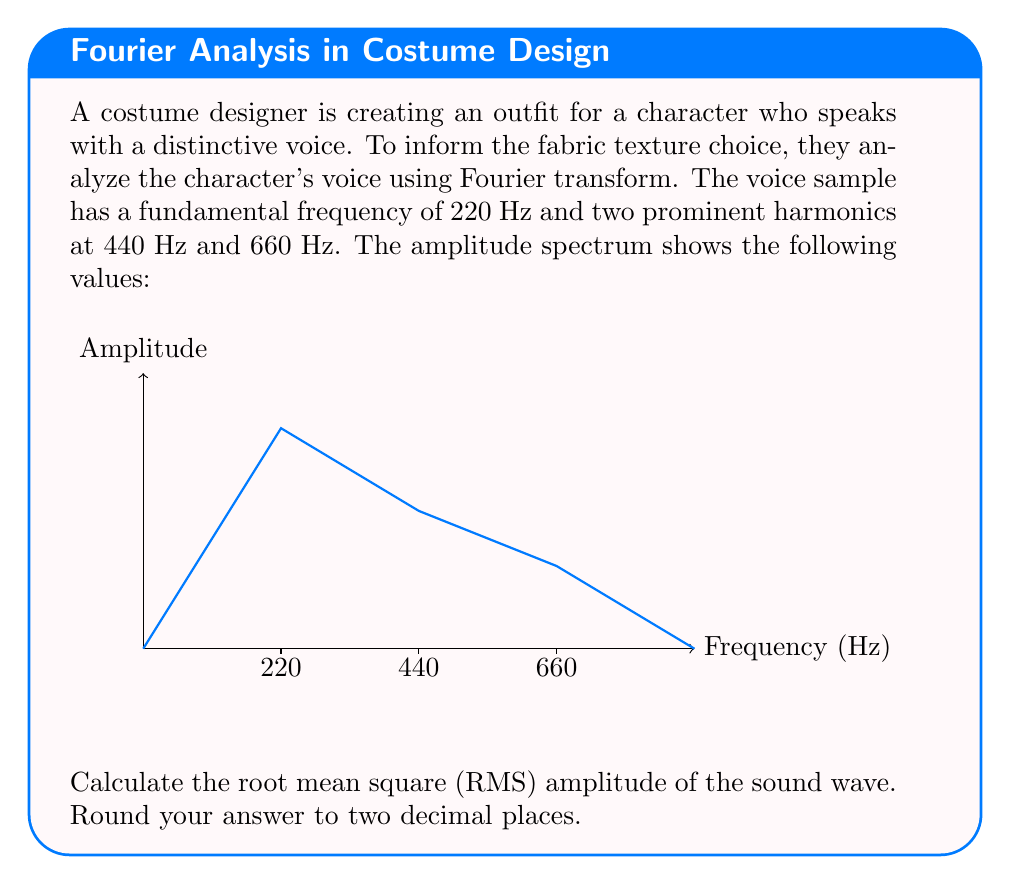Teach me how to tackle this problem. To calculate the RMS amplitude of the sound wave, we'll follow these steps:

1) The RMS amplitude is given by the formula:

   $$A_{RMS} = \sqrt{\frac{1}{2}\sum_{i=1}^{n} A_i^2}$$

   where $A_i$ are the amplitudes of each frequency component.

2) From the amplitude spectrum, we can see:
   $A_1 = 80$ (at 220 Hz)
   $A_2 = 50$ (at 440 Hz)
   $A_3 = 30$ (at 660 Hz)

3) Substituting these values into the formula:

   $$A_{RMS} = \sqrt{\frac{1}{2}(80^2 + 50^2 + 30^2)}$$

4) Simplify inside the parentheses:
   
   $$A_{RMS} = \sqrt{\frac{1}{2}(6400 + 2500 + 900)}$$
   $$A_{RMS} = \sqrt{\frac{1}{2}(9800)}$$

5) Simplify further:
   
   $$A_{RMS} = \sqrt{4900}$$

6) Calculate the square root:
   
   $$A_{RMS} = 70$$

7) Rounding to two decimal places:
   
   $$A_{RMS} \approx 70.00$$

This RMS amplitude can inform the costume designer about the overall "strength" or "roughness" of the voice, which can be translated into fabric texture choices.
Answer: 70.00 